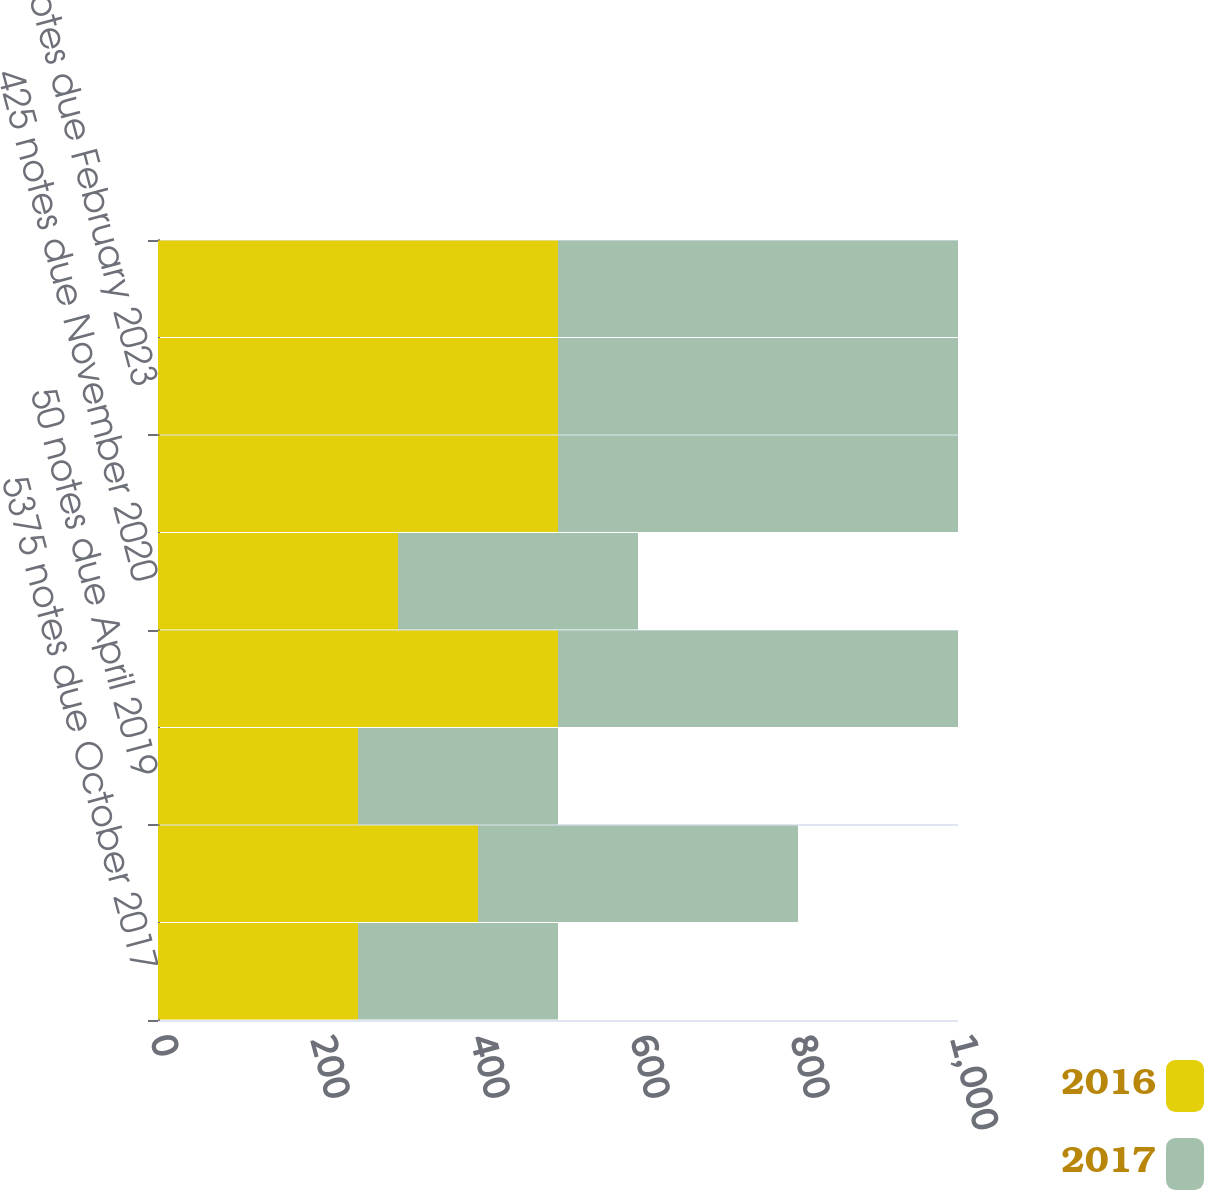<chart> <loc_0><loc_0><loc_500><loc_500><stacked_bar_chart><ecel><fcel>5375 notes due October 2017<fcel>525 notes due October 2018<fcel>50 notes due April 2019<fcel>4875 notes due October 2019<fcel>425 notes due November 2020<fcel>2625 notes due December 2021<fcel>2625 notes due February 2023<fcel>315 notes due June 2025<nl><fcel>2016<fcel>250<fcel>400<fcel>250<fcel>500<fcel>300<fcel>500<fcel>500<fcel>500<nl><fcel>2017<fcel>250<fcel>400<fcel>250<fcel>500<fcel>300<fcel>500<fcel>500<fcel>500<nl></chart> 